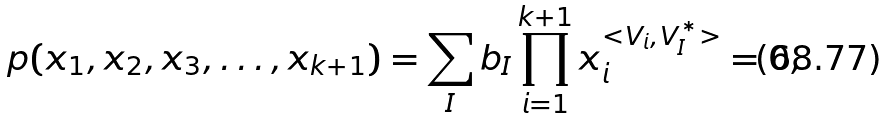Convert formula to latex. <formula><loc_0><loc_0><loc_500><loc_500>p ( x _ { 1 } , x _ { 2 } , x _ { 3 } , \dots , x _ { k + 1 } ) = \sum _ { I } b _ { I } \prod _ { i = 1 } ^ { k + 1 } x _ { i } ^ { < { V } _ { i } , { V } _ { I } ^ { \ast } > } = 0 ,</formula> 